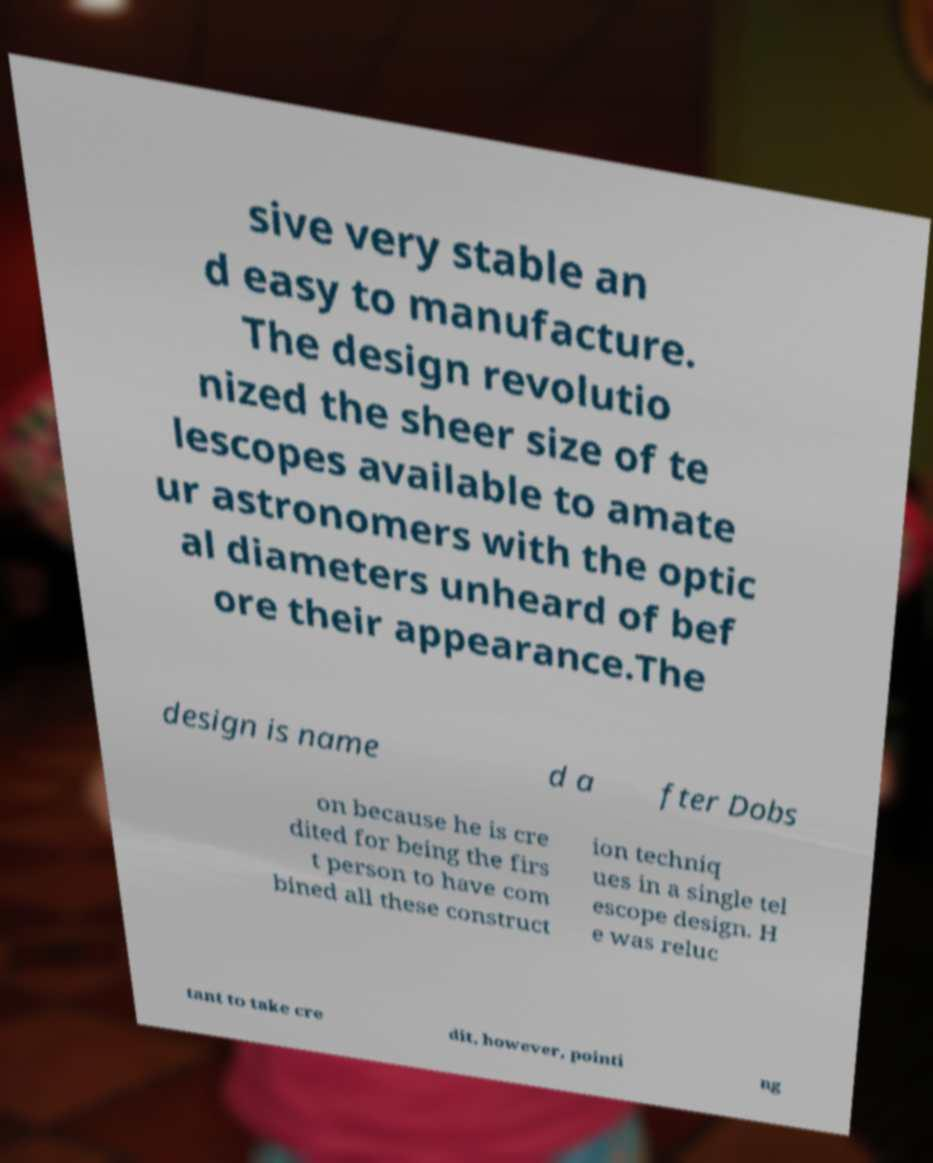Can you accurately transcribe the text from the provided image for me? sive very stable an d easy to manufacture. The design revolutio nized the sheer size of te lescopes available to amate ur astronomers with the optic al diameters unheard of bef ore their appearance.The design is name d a fter Dobs on because he is cre dited for being the firs t person to have com bined all these construct ion techniq ues in a single tel escope design. H e was reluc tant to take cre dit, however, pointi ng 